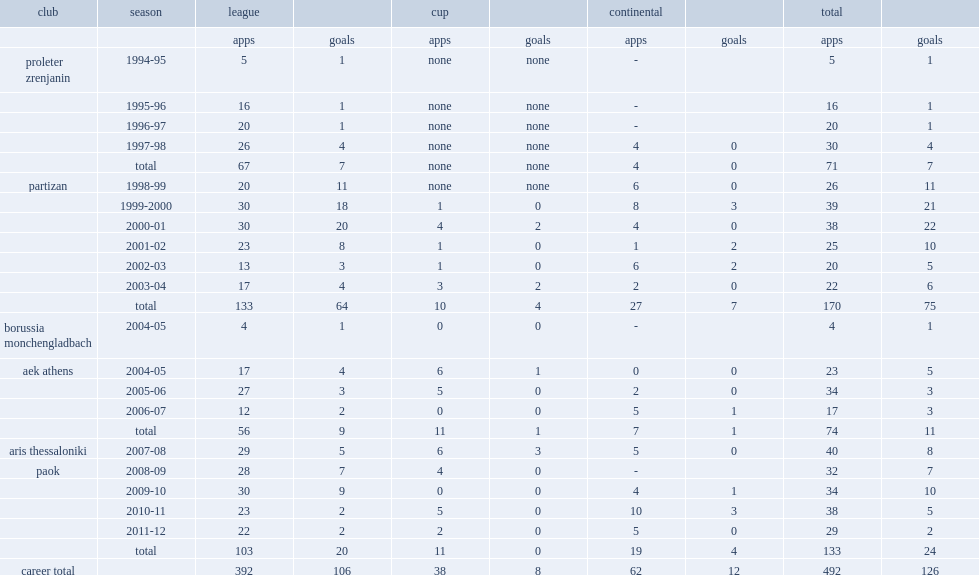Could you help me parse every detail presented in this table? {'header': ['club', 'season', 'league', '', 'cup', '', 'continental', '', 'total', ''], 'rows': [['', '', 'apps', 'goals', 'apps', 'goals', 'apps', 'goals', 'apps', 'goals'], ['proleter zrenjanin', '1994-95', '5', '1', 'none', 'none', '-', '', '5', '1'], ['', '1995-96', '16', '1', 'none', 'none', '-', '', '16', '1'], ['', '1996-97', '20', '1', 'none', 'none', '-', '', '20', '1'], ['', '1997-98', '26', '4', 'none', 'none', '4', '0', '30', '4'], ['', 'total', '67', '7', 'none', 'none', '4', '0', '71', '7'], ['partizan', '1998-99', '20', '11', 'none', 'none', '6', '0', '26', '11'], ['', '1999-2000', '30', '18', '1', '0', '8', '3', '39', '21'], ['', '2000-01', '30', '20', '4', '2', '4', '0', '38', '22'], ['', '2001-02', '23', '8', '1', '0', '1', '2', '25', '10'], ['', '2002-03', '13', '3', '1', '0', '6', '2', '20', '5'], ['', '2003-04', '17', '4', '3', '2', '2', '0', '22', '6'], ['', 'total', '133', '64', '10', '4', '27', '7', '170', '75'], ['borussia monchengladbach', '2004-05', '4', '1', '0', '0', '-', '', '4', '1'], ['aek athens', '2004-05', '17', '4', '6', '1', '0', '0', '23', '5'], ['', '2005-06', '27', '3', '5', '0', '2', '0', '34', '3'], ['', '2006-07', '12', '2', '0', '0', '5', '1', '17', '3'], ['', 'total', '56', '9', '11', '1', '7', '1', '74', '11'], ['aris thessaloniki', '2007-08', '29', '5', '6', '3', '5', '0', '40', '8'], ['paok', '2008-09', '28', '7', '4', '0', '-', '', '32', '7'], ['', '2009-10', '30', '9', '0', '0', '4', '1', '34', '10'], ['', '2010-11', '23', '2', '5', '0', '10', '3', '38', '5'], ['', '2011-12', '22', '2', '2', '0', '5', '0', '29', '2'], ['', 'total', '103', '20', '11', '0', '19', '4', '133', '24'], ['career total', '', '392', '106', '38', '8', '62', '12', '492', '126']]} How many appearances did vladimir ivic make in total with 64 league goals? 133.0. 